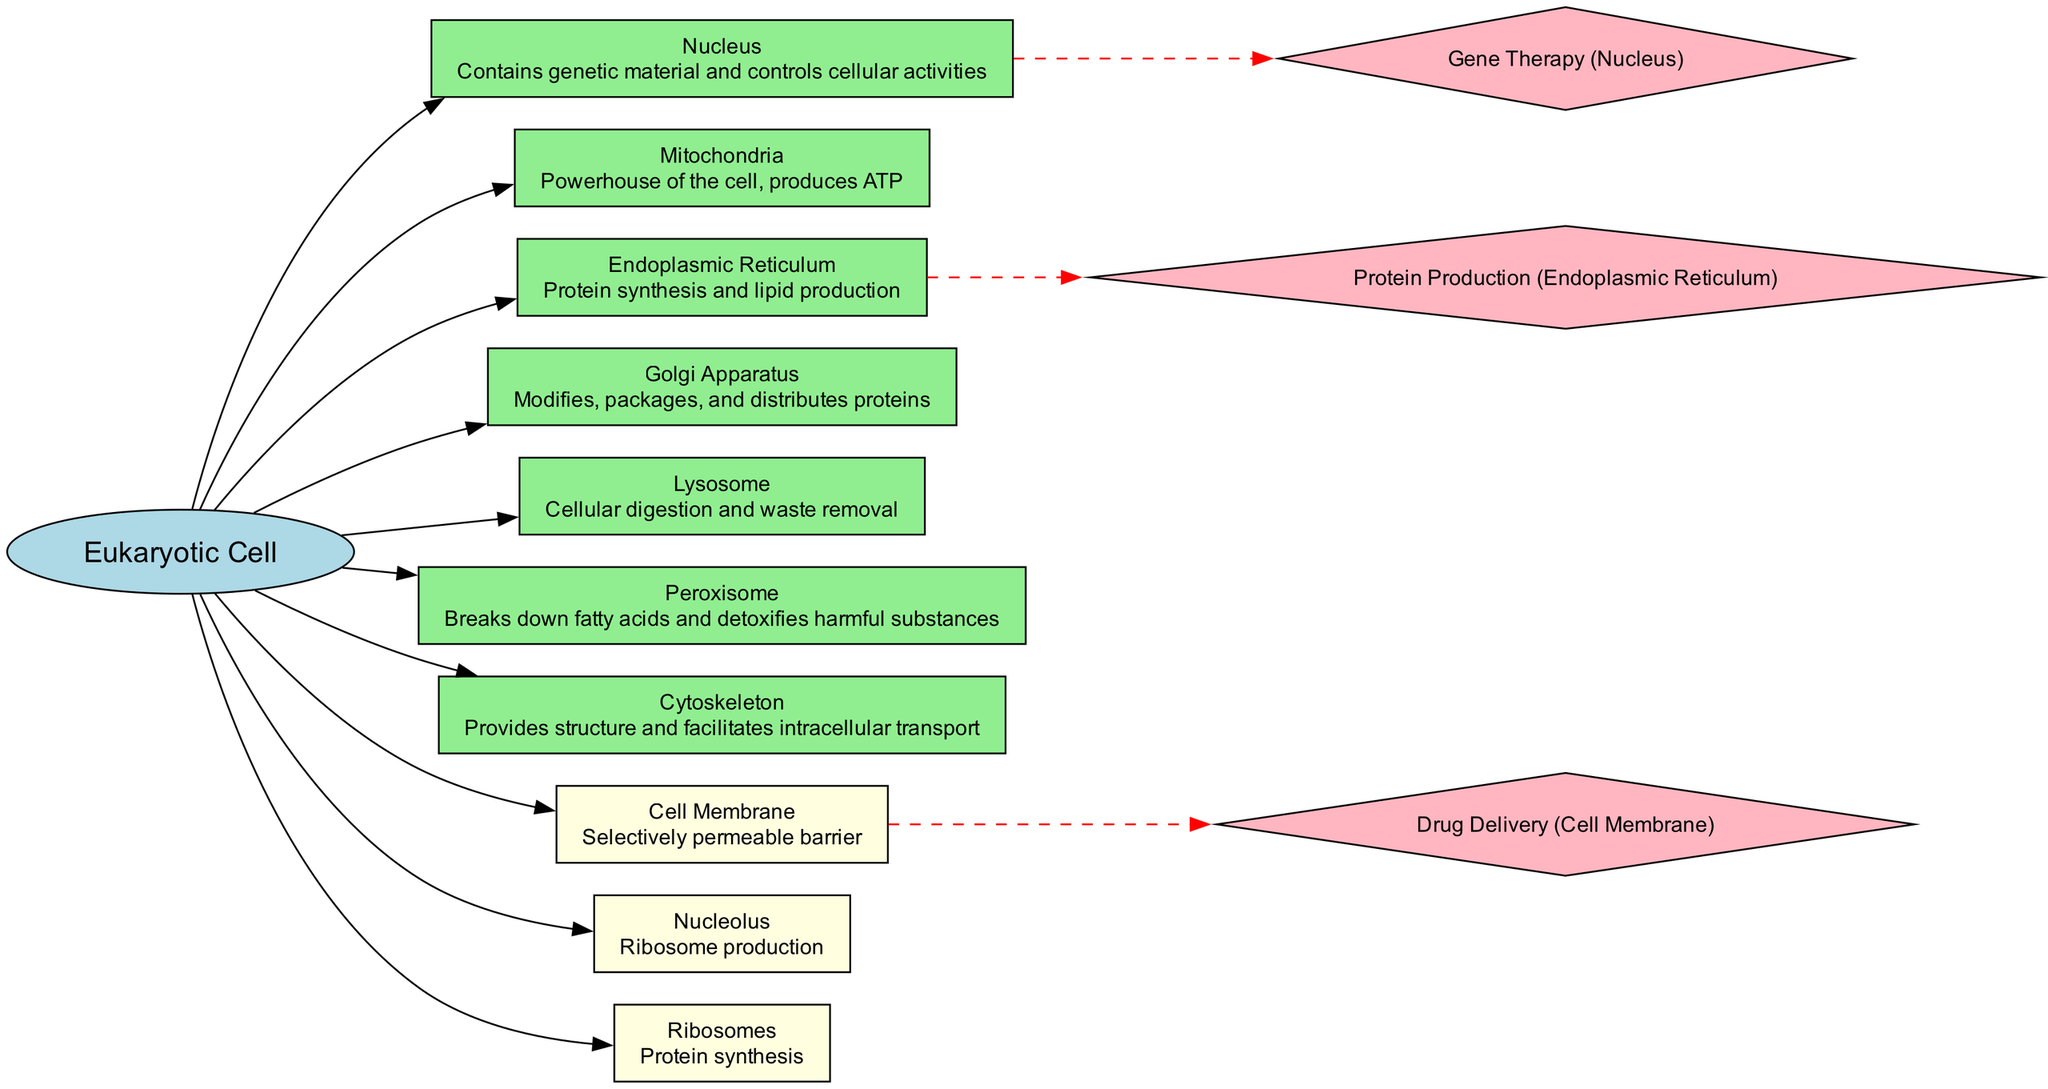What is the central node of the diagram? The diagram clearly identifies the "Eukaryotic Cell" as the central node, as indicated by its placement in the center with an elliptical shape.
Answer: Eukaryotic Cell How many organelles are highlighted in the diagram? By counting the organelle nodes that are connected to the central node, we find that there are six organelles depicted.
Answer: 6 What is the function of the Golgi Apparatus? The diagram specifies that the Golgi Apparatus is responsible for modifying, packaging, and distributing proteins, which is indicated on its node.
Answer: Modifies, packages, and distributes proteins Which organelle is associated with energy production? The diagram identifies mitochondria as the organelle responsible for energy production, specifically as the "Powerhouse of the cell," which is stated on its node.
Answer: Mitochondria What is the function of the Nucleolus? The diagram provides that the Nucleolus is involved in ribosome production, which is highlighted on its associated node.
Answer: Ribosome production Which specialized feature acts as a selectively permeable barrier? According to the diagram, the Cell Membrane serves as a selectively permeable barrier, as described in its node information.
Answer: Cell Membrane How is gene therapy related to the eukaryotic cell? The diagram shows that gene therapy targets the nucleus, indicating the relationship by connecting the term "Gene Therapy" to the nucleus with a dashed line.
Answer: Nucleus Which organelle is responsible for cellular digestion? The diagram highlights the lysosome as the organelle responsible for cellular digestion, referring to its function directly on the node.
Answer: Lysosome What type of applications are associated with the Endoplasmic Reticulum? The diagram indicates that the Endoplasmic Reticulum is crucial for protein production, which is explicitly noted next to its description on the diagram.
Answer: Protein Production 